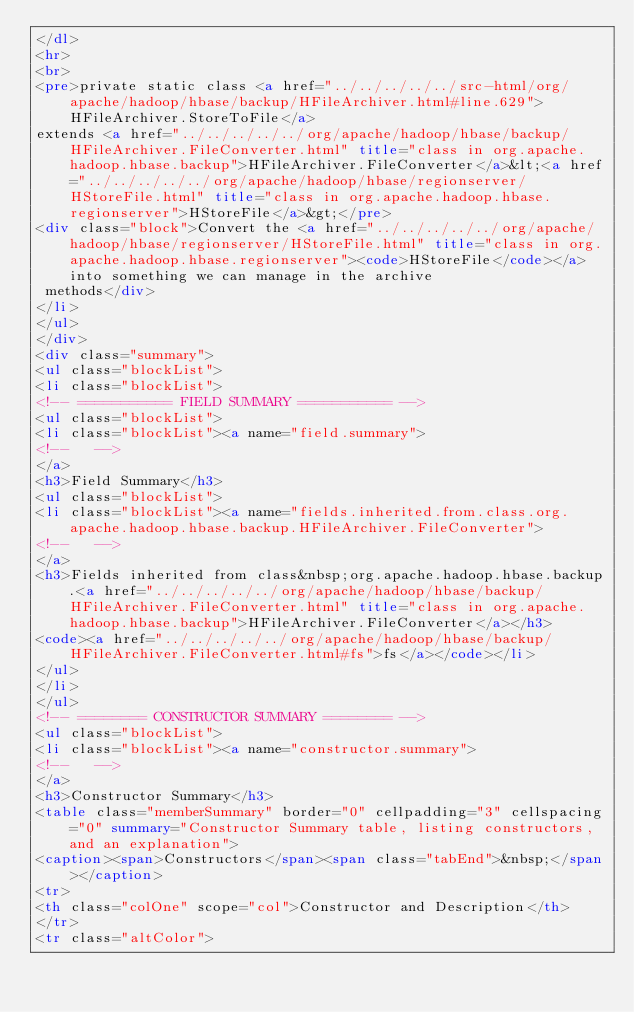<code> <loc_0><loc_0><loc_500><loc_500><_HTML_></dl>
<hr>
<br>
<pre>private static class <a href="../../../../../src-html/org/apache/hadoop/hbase/backup/HFileArchiver.html#line.629">HFileArchiver.StoreToFile</a>
extends <a href="../../../../../org/apache/hadoop/hbase/backup/HFileArchiver.FileConverter.html" title="class in org.apache.hadoop.hbase.backup">HFileArchiver.FileConverter</a>&lt;<a href="../../../../../org/apache/hadoop/hbase/regionserver/HStoreFile.html" title="class in org.apache.hadoop.hbase.regionserver">HStoreFile</a>&gt;</pre>
<div class="block">Convert the <a href="../../../../../org/apache/hadoop/hbase/regionserver/HStoreFile.html" title="class in org.apache.hadoop.hbase.regionserver"><code>HStoreFile</code></a> into something we can manage in the archive
 methods</div>
</li>
</ul>
</div>
<div class="summary">
<ul class="blockList">
<li class="blockList">
<!-- =========== FIELD SUMMARY =========== -->
<ul class="blockList">
<li class="blockList"><a name="field.summary">
<!--   -->
</a>
<h3>Field Summary</h3>
<ul class="blockList">
<li class="blockList"><a name="fields.inherited.from.class.org.apache.hadoop.hbase.backup.HFileArchiver.FileConverter">
<!--   -->
</a>
<h3>Fields inherited from class&nbsp;org.apache.hadoop.hbase.backup.<a href="../../../../../org/apache/hadoop/hbase/backup/HFileArchiver.FileConverter.html" title="class in org.apache.hadoop.hbase.backup">HFileArchiver.FileConverter</a></h3>
<code><a href="../../../../../org/apache/hadoop/hbase/backup/HFileArchiver.FileConverter.html#fs">fs</a></code></li>
</ul>
</li>
</ul>
<!-- ======== CONSTRUCTOR SUMMARY ======== -->
<ul class="blockList">
<li class="blockList"><a name="constructor.summary">
<!--   -->
</a>
<h3>Constructor Summary</h3>
<table class="memberSummary" border="0" cellpadding="3" cellspacing="0" summary="Constructor Summary table, listing constructors, and an explanation">
<caption><span>Constructors</span><span class="tabEnd">&nbsp;</span></caption>
<tr>
<th class="colOne" scope="col">Constructor and Description</th>
</tr>
<tr class="altColor"></code> 